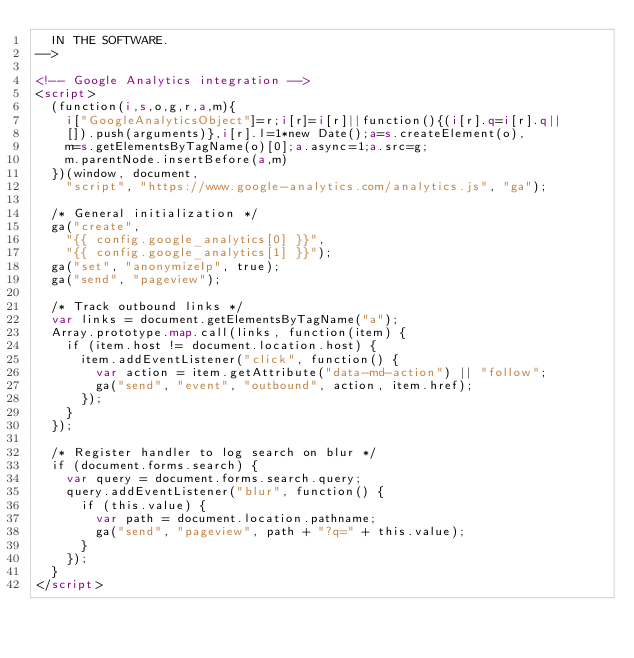<code> <loc_0><loc_0><loc_500><loc_500><_HTML_>  IN THE SOFTWARE.
-->

<!-- Google Analytics integration -->
<script>
  (function(i,s,o,g,r,a,m){
    i["GoogleAnalyticsObject"]=r;i[r]=i[r]||function(){(i[r].q=i[r].q||
    []).push(arguments)},i[r].l=1*new Date();a=s.createElement(o),
    m=s.getElementsByTagName(o)[0];a.async=1;a.src=g;
    m.parentNode.insertBefore(a,m)
  })(window, document,
    "script", "https://www.google-analytics.com/analytics.js", "ga");

  /* General initialization */
  ga("create",
    "{{ config.google_analytics[0] }}",
    "{{ config.google_analytics[1] }}");
  ga("set", "anonymizeIp", true);
  ga("send", "pageview");

  /* Track outbound links */
  var links = document.getElementsByTagName("a");
  Array.prototype.map.call(links, function(item) {
    if (item.host != document.location.host) {
      item.addEventListener("click", function() {
        var action = item.getAttribute("data-md-action") || "follow";
        ga("send", "event", "outbound", action, item.href);
      });
    }
  });

  /* Register handler to log search on blur */
  if (document.forms.search) {
    var query = document.forms.search.query;
    query.addEventListener("blur", function() {
      if (this.value) {
        var path = document.location.pathname;
        ga("send", "pageview", path + "?q=" + this.value);
      }
    });
  }
</script>
</code> 